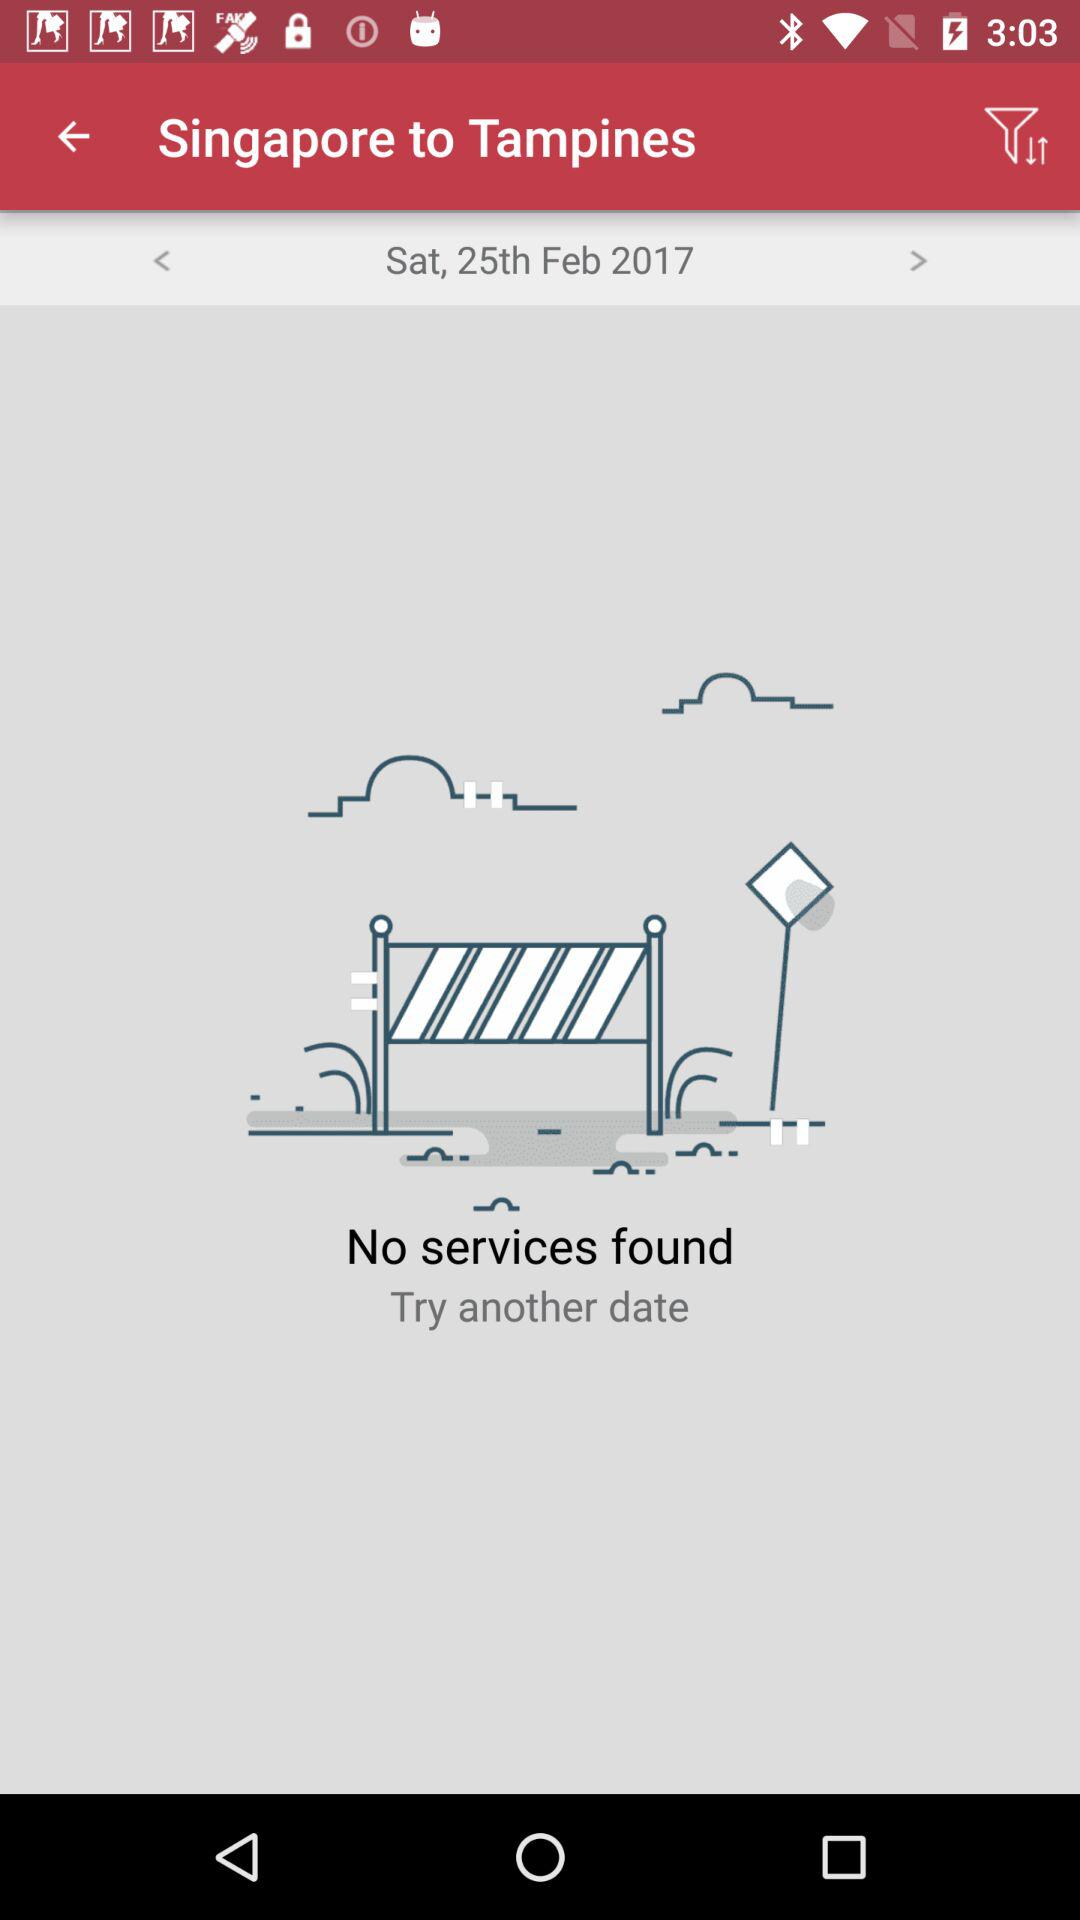What is the given date? The given date is Saturday, February 25th, 2017. 